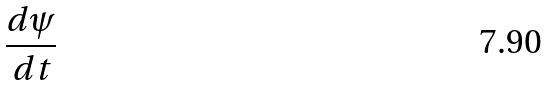<formula> <loc_0><loc_0><loc_500><loc_500>\frac { d \psi } { d t }</formula> 